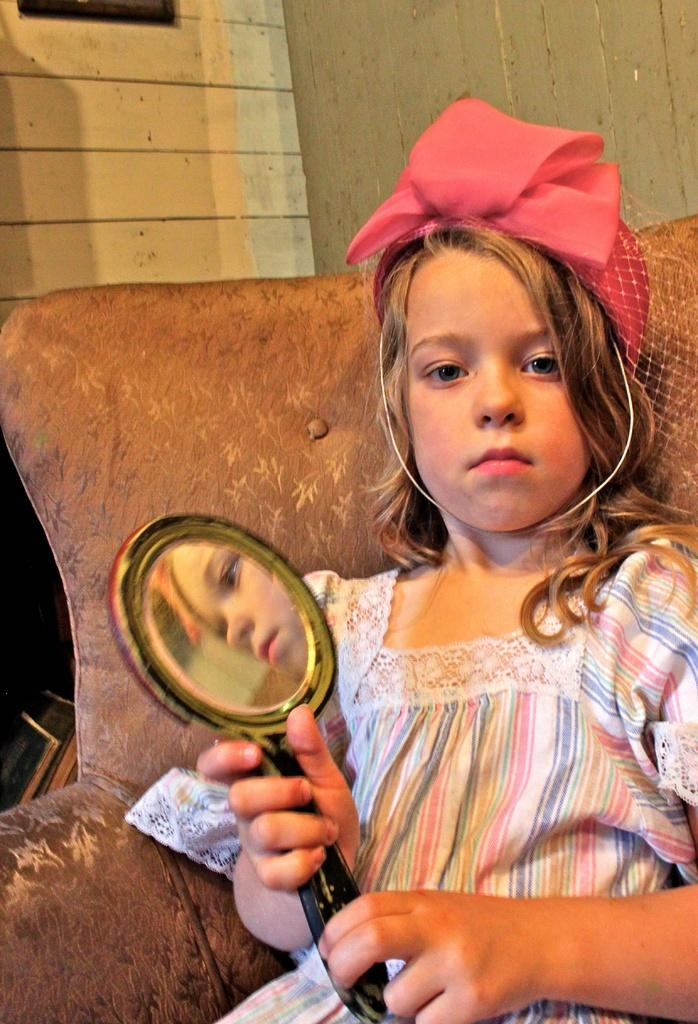Who is the main subject in the foreground of the image? There is a girl in the foreground of the image. What is the girl doing in the image? The girl is sitting on a sofa. What object is the girl holding in the image? The girl is holding a mirror. What accessory is the girl wearing on her head? The girl is wearing a headband on her head. What can be seen in the background of the image? There is a wall in the background of the image. What type of soda is the girl drinking in the image? There is no soda present in the image; the girl is holding a mirror and wearing a headband. 